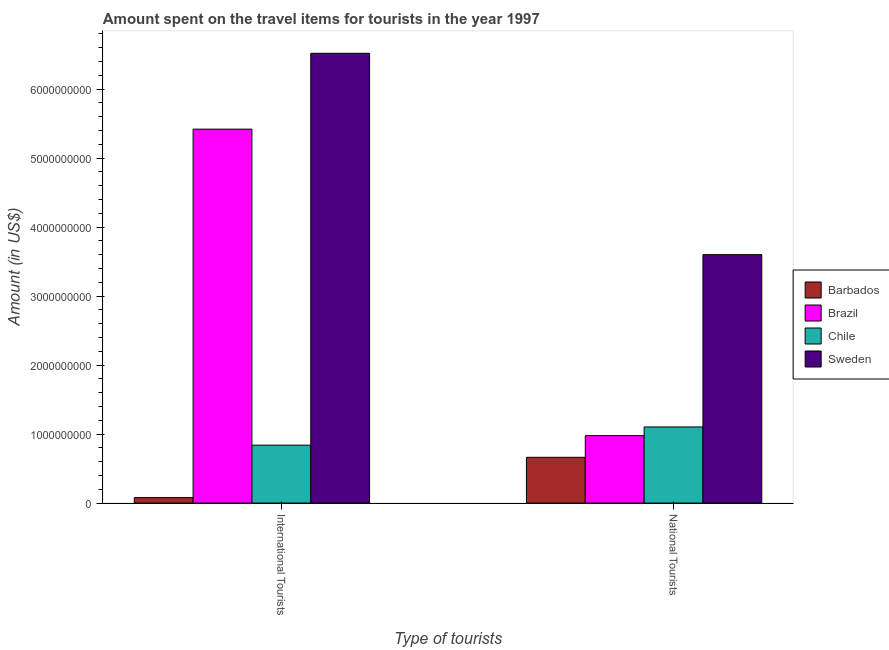How many bars are there on the 2nd tick from the left?
Offer a terse response. 4. How many bars are there on the 1st tick from the right?
Provide a succinct answer. 4. What is the label of the 2nd group of bars from the left?
Provide a short and direct response. National Tourists. What is the amount spent on travel items of national tourists in Brazil?
Offer a very short reply. 9.77e+08. Across all countries, what is the maximum amount spent on travel items of national tourists?
Ensure brevity in your answer.  3.60e+09. Across all countries, what is the minimum amount spent on travel items of national tourists?
Give a very brief answer. 6.63e+08. In which country was the amount spent on travel items of national tourists minimum?
Your response must be concise. Barbados. What is the total amount spent on travel items of international tourists in the graph?
Your answer should be very brief. 1.29e+1. What is the difference between the amount spent on travel items of national tourists in Sweden and that in Brazil?
Make the answer very short. 2.62e+09. What is the difference between the amount spent on travel items of international tourists in Sweden and the amount spent on travel items of national tourists in Chile?
Offer a very short reply. 5.42e+09. What is the average amount spent on travel items of international tourists per country?
Provide a succinct answer. 3.21e+09. What is the difference between the amount spent on travel items of national tourists and amount spent on travel items of international tourists in Brazil?
Your answer should be compact. -4.44e+09. What is the ratio of the amount spent on travel items of international tourists in Sweden to that in Barbados?
Offer a very short reply. 82.51. What does the 4th bar from the left in International Tourists represents?
Your answer should be compact. Sweden. Are all the bars in the graph horizontal?
Make the answer very short. No. Does the graph contain grids?
Give a very brief answer. No. Where does the legend appear in the graph?
Offer a terse response. Center right. How are the legend labels stacked?
Offer a very short reply. Vertical. What is the title of the graph?
Provide a succinct answer. Amount spent on the travel items for tourists in the year 1997. Does "Turkmenistan" appear as one of the legend labels in the graph?
Provide a succinct answer. No. What is the label or title of the X-axis?
Offer a terse response. Type of tourists. What is the label or title of the Y-axis?
Offer a terse response. Amount (in US$). What is the Amount (in US$) of Barbados in International Tourists?
Offer a very short reply. 7.90e+07. What is the Amount (in US$) of Brazil in International Tourists?
Ensure brevity in your answer.  5.42e+09. What is the Amount (in US$) of Chile in International Tourists?
Offer a very short reply. 8.39e+08. What is the Amount (in US$) of Sweden in International Tourists?
Offer a very short reply. 6.52e+09. What is the Amount (in US$) in Barbados in National Tourists?
Keep it short and to the point. 6.63e+08. What is the Amount (in US$) in Brazil in National Tourists?
Ensure brevity in your answer.  9.77e+08. What is the Amount (in US$) in Chile in National Tourists?
Make the answer very short. 1.10e+09. What is the Amount (in US$) in Sweden in National Tourists?
Keep it short and to the point. 3.60e+09. Across all Type of tourists, what is the maximum Amount (in US$) in Barbados?
Give a very brief answer. 6.63e+08. Across all Type of tourists, what is the maximum Amount (in US$) of Brazil?
Your answer should be compact. 5.42e+09. Across all Type of tourists, what is the maximum Amount (in US$) in Chile?
Offer a very short reply. 1.10e+09. Across all Type of tourists, what is the maximum Amount (in US$) of Sweden?
Ensure brevity in your answer.  6.52e+09. Across all Type of tourists, what is the minimum Amount (in US$) of Barbados?
Offer a very short reply. 7.90e+07. Across all Type of tourists, what is the minimum Amount (in US$) in Brazil?
Offer a terse response. 9.77e+08. Across all Type of tourists, what is the minimum Amount (in US$) of Chile?
Offer a terse response. 8.39e+08. Across all Type of tourists, what is the minimum Amount (in US$) of Sweden?
Provide a succinct answer. 3.60e+09. What is the total Amount (in US$) in Barbados in the graph?
Your response must be concise. 7.42e+08. What is the total Amount (in US$) in Brazil in the graph?
Your response must be concise. 6.40e+09. What is the total Amount (in US$) in Chile in the graph?
Your response must be concise. 1.94e+09. What is the total Amount (in US$) of Sweden in the graph?
Keep it short and to the point. 1.01e+1. What is the difference between the Amount (in US$) of Barbados in International Tourists and that in National Tourists?
Provide a short and direct response. -5.84e+08. What is the difference between the Amount (in US$) of Brazil in International Tourists and that in National Tourists?
Offer a terse response. 4.44e+09. What is the difference between the Amount (in US$) of Chile in International Tourists and that in National Tourists?
Offer a terse response. -2.64e+08. What is the difference between the Amount (in US$) of Sweden in International Tourists and that in National Tourists?
Offer a very short reply. 2.92e+09. What is the difference between the Amount (in US$) in Barbados in International Tourists and the Amount (in US$) in Brazil in National Tourists?
Make the answer very short. -8.98e+08. What is the difference between the Amount (in US$) in Barbados in International Tourists and the Amount (in US$) in Chile in National Tourists?
Ensure brevity in your answer.  -1.02e+09. What is the difference between the Amount (in US$) of Barbados in International Tourists and the Amount (in US$) of Sweden in National Tourists?
Make the answer very short. -3.52e+09. What is the difference between the Amount (in US$) in Brazil in International Tourists and the Amount (in US$) in Chile in National Tourists?
Keep it short and to the point. 4.32e+09. What is the difference between the Amount (in US$) in Brazil in International Tourists and the Amount (in US$) in Sweden in National Tourists?
Your response must be concise. 1.82e+09. What is the difference between the Amount (in US$) in Chile in International Tourists and the Amount (in US$) in Sweden in National Tourists?
Your answer should be compact. -2.76e+09. What is the average Amount (in US$) of Barbados per Type of tourists?
Give a very brief answer. 3.71e+08. What is the average Amount (in US$) in Brazil per Type of tourists?
Your answer should be very brief. 3.20e+09. What is the average Amount (in US$) of Chile per Type of tourists?
Provide a short and direct response. 9.71e+08. What is the average Amount (in US$) of Sweden per Type of tourists?
Give a very brief answer. 5.06e+09. What is the difference between the Amount (in US$) in Barbados and Amount (in US$) in Brazil in International Tourists?
Provide a succinct answer. -5.34e+09. What is the difference between the Amount (in US$) in Barbados and Amount (in US$) in Chile in International Tourists?
Provide a short and direct response. -7.60e+08. What is the difference between the Amount (in US$) in Barbados and Amount (in US$) in Sweden in International Tourists?
Your response must be concise. -6.44e+09. What is the difference between the Amount (in US$) in Brazil and Amount (in US$) in Chile in International Tourists?
Provide a succinct answer. 4.58e+09. What is the difference between the Amount (in US$) of Brazil and Amount (in US$) of Sweden in International Tourists?
Your answer should be very brief. -1.10e+09. What is the difference between the Amount (in US$) in Chile and Amount (in US$) in Sweden in International Tourists?
Offer a terse response. -5.68e+09. What is the difference between the Amount (in US$) of Barbados and Amount (in US$) of Brazil in National Tourists?
Make the answer very short. -3.14e+08. What is the difference between the Amount (in US$) in Barbados and Amount (in US$) in Chile in National Tourists?
Keep it short and to the point. -4.40e+08. What is the difference between the Amount (in US$) of Barbados and Amount (in US$) of Sweden in National Tourists?
Your response must be concise. -2.94e+09. What is the difference between the Amount (in US$) in Brazil and Amount (in US$) in Chile in National Tourists?
Give a very brief answer. -1.26e+08. What is the difference between the Amount (in US$) of Brazil and Amount (in US$) of Sweden in National Tourists?
Give a very brief answer. -2.62e+09. What is the difference between the Amount (in US$) in Chile and Amount (in US$) in Sweden in National Tourists?
Offer a terse response. -2.50e+09. What is the ratio of the Amount (in US$) of Barbados in International Tourists to that in National Tourists?
Make the answer very short. 0.12. What is the ratio of the Amount (in US$) of Brazil in International Tourists to that in National Tourists?
Give a very brief answer. 5.55. What is the ratio of the Amount (in US$) of Chile in International Tourists to that in National Tourists?
Your answer should be very brief. 0.76. What is the ratio of the Amount (in US$) in Sweden in International Tourists to that in National Tourists?
Make the answer very short. 1.81. What is the difference between the highest and the second highest Amount (in US$) of Barbados?
Your response must be concise. 5.84e+08. What is the difference between the highest and the second highest Amount (in US$) of Brazil?
Keep it short and to the point. 4.44e+09. What is the difference between the highest and the second highest Amount (in US$) in Chile?
Offer a terse response. 2.64e+08. What is the difference between the highest and the second highest Amount (in US$) of Sweden?
Your response must be concise. 2.92e+09. What is the difference between the highest and the lowest Amount (in US$) of Barbados?
Keep it short and to the point. 5.84e+08. What is the difference between the highest and the lowest Amount (in US$) of Brazil?
Give a very brief answer. 4.44e+09. What is the difference between the highest and the lowest Amount (in US$) in Chile?
Give a very brief answer. 2.64e+08. What is the difference between the highest and the lowest Amount (in US$) in Sweden?
Ensure brevity in your answer.  2.92e+09. 